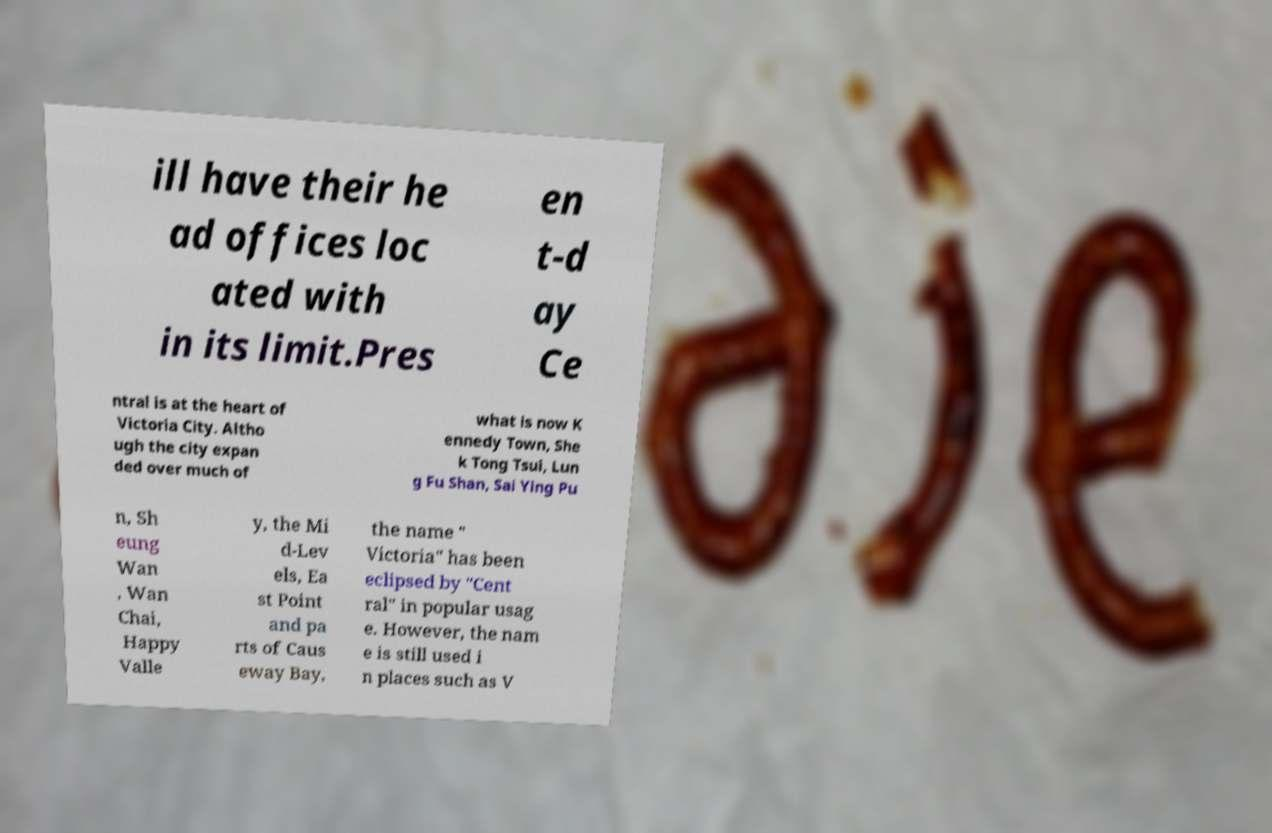There's text embedded in this image that I need extracted. Can you transcribe it verbatim? ill have their he ad offices loc ated with in its limit.Pres en t-d ay Ce ntral is at the heart of Victoria City. Altho ugh the city expan ded over much of what is now K ennedy Town, She k Tong Tsui, Lun g Fu Shan, Sai Ying Pu n, Sh eung Wan , Wan Chai, Happy Valle y, the Mi d-Lev els, Ea st Point and pa rts of Caus eway Bay, the name " Victoria" has been eclipsed by "Cent ral" in popular usag e. However, the nam e is still used i n places such as V 